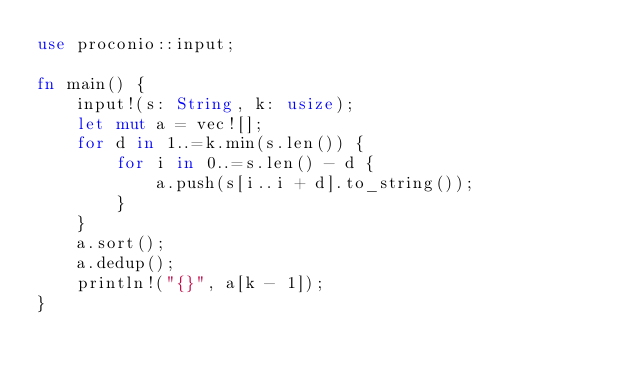Convert code to text. <code><loc_0><loc_0><loc_500><loc_500><_Rust_>use proconio::input;

fn main() {
    input!(s: String, k: usize);
    let mut a = vec![];
    for d in 1..=k.min(s.len()) {
        for i in 0..=s.len() - d {
            a.push(s[i..i + d].to_string());
        }
    }
    a.sort();
    a.dedup();
    println!("{}", a[k - 1]);
}
</code> 